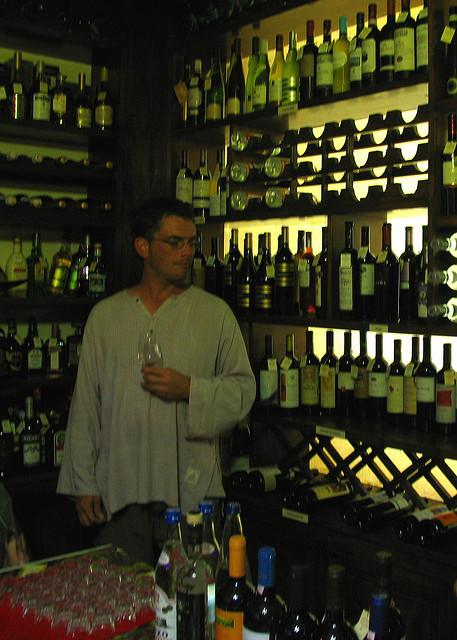Where is the man? Please explain your reasoning. wine store. The man is selling some wine since there are bottles behind him. 